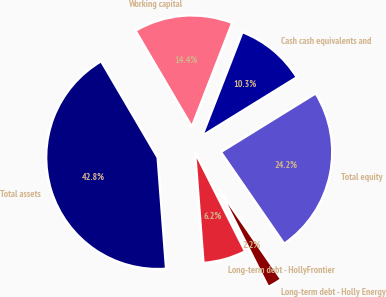<chart> <loc_0><loc_0><loc_500><loc_500><pie_chart><fcel>Cash cash equivalents and<fcel>Working capital<fcel>Total assets<fcel>Long-term debt - HollyFrontier<fcel>Long-term debt - Holly Energy<fcel>Total equity<nl><fcel>10.29%<fcel>14.35%<fcel>42.75%<fcel>6.24%<fcel>2.18%<fcel>24.19%<nl></chart> 